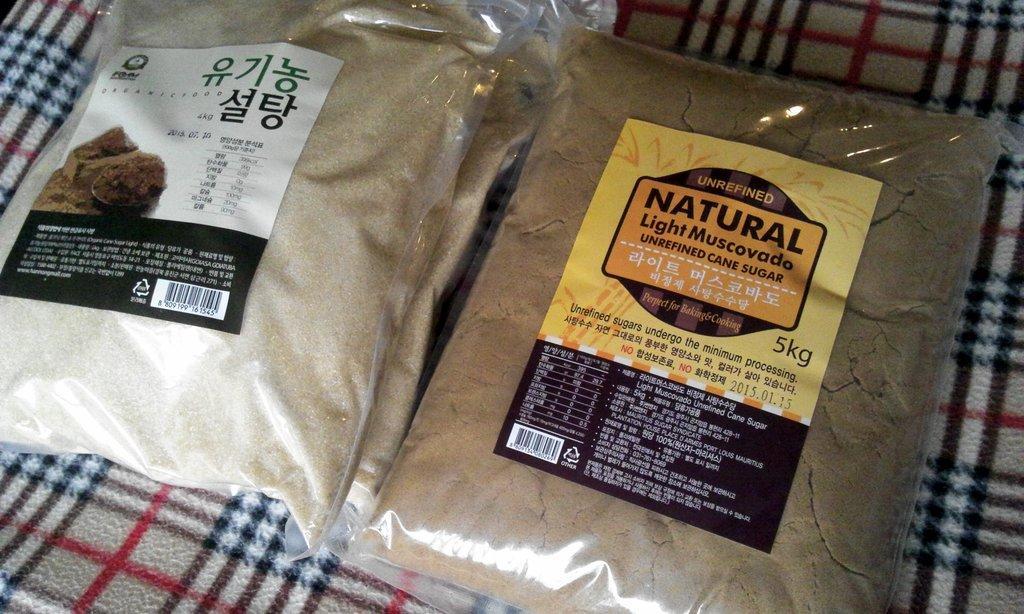Could you give a brief overview of what you see in this image? In this picture we can see the sugar packets are present on a blanket. 